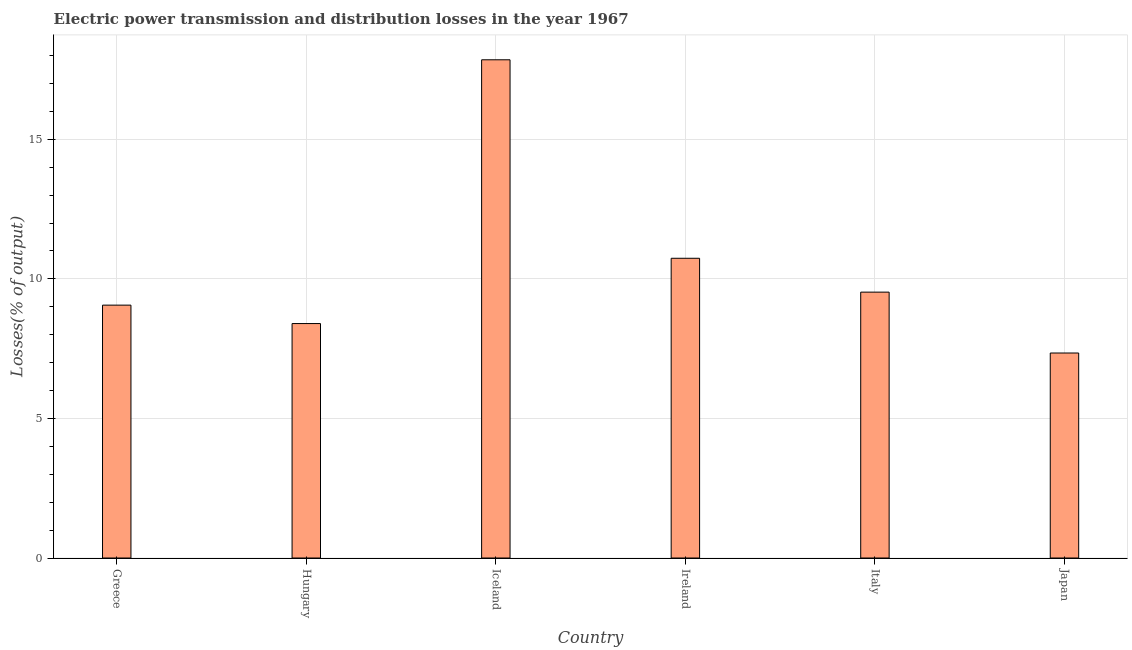Does the graph contain any zero values?
Your answer should be compact. No. What is the title of the graph?
Offer a very short reply. Electric power transmission and distribution losses in the year 1967. What is the label or title of the X-axis?
Your response must be concise. Country. What is the label or title of the Y-axis?
Make the answer very short. Losses(% of output). What is the electric power transmission and distribution losses in Italy?
Your answer should be compact. 9.52. Across all countries, what is the maximum electric power transmission and distribution losses?
Provide a short and direct response. 17.85. Across all countries, what is the minimum electric power transmission and distribution losses?
Keep it short and to the point. 7.34. What is the sum of the electric power transmission and distribution losses?
Offer a very short reply. 62.91. What is the difference between the electric power transmission and distribution losses in Hungary and Japan?
Offer a very short reply. 1.05. What is the average electric power transmission and distribution losses per country?
Your response must be concise. 10.48. What is the median electric power transmission and distribution losses?
Your answer should be very brief. 9.29. In how many countries, is the electric power transmission and distribution losses greater than 14 %?
Offer a terse response. 1. What is the ratio of the electric power transmission and distribution losses in Iceland to that in Italy?
Offer a terse response. 1.87. Is the difference between the electric power transmission and distribution losses in Ireland and Japan greater than the difference between any two countries?
Ensure brevity in your answer.  No. What is the difference between the highest and the second highest electric power transmission and distribution losses?
Ensure brevity in your answer.  7.11. Is the sum of the electric power transmission and distribution losses in Iceland and Ireland greater than the maximum electric power transmission and distribution losses across all countries?
Your answer should be compact. Yes. In how many countries, is the electric power transmission and distribution losses greater than the average electric power transmission and distribution losses taken over all countries?
Offer a very short reply. 2. What is the difference between two consecutive major ticks on the Y-axis?
Your answer should be very brief. 5. Are the values on the major ticks of Y-axis written in scientific E-notation?
Your answer should be compact. No. What is the Losses(% of output) in Greece?
Provide a succinct answer. 9.06. What is the Losses(% of output) in Hungary?
Ensure brevity in your answer.  8.4. What is the Losses(% of output) of Iceland?
Offer a terse response. 17.85. What is the Losses(% of output) in Ireland?
Offer a very short reply. 10.74. What is the Losses(% of output) of Italy?
Your response must be concise. 9.52. What is the Losses(% of output) of Japan?
Offer a very short reply. 7.34. What is the difference between the Losses(% of output) in Greece and Hungary?
Provide a short and direct response. 0.66. What is the difference between the Losses(% of output) in Greece and Iceland?
Keep it short and to the point. -8.79. What is the difference between the Losses(% of output) in Greece and Ireland?
Give a very brief answer. -1.68. What is the difference between the Losses(% of output) in Greece and Italy?
Offer a terse response. -0.47. What is the difference between the Losses(% of output) in Greece and Japan?
Keep it short and to the point. 1.71. What is the difference between the Losses(% of output) in Hungary and Iceland?
Offer a very short reply. -9.45. What is the difference between the Losses(% of output) in Hungary and Ireland?
Make the answer very short. -2.34. What is the difference between the Losses(% of output) in Hungary and Italy?
Offer a very short reply. -1.13. What is the difference between the Losses(% of output) in Hungary and Japan?
Provide a short and direct response. 1.06. What is the difference between the Losses(% of output) in Iceland and Ireland?
Give a very brief answer. 7.11. What is the difference between the Losses(% of output) in Iceland and Italy?
Offer a terse response. 8.32. What is the difference between the Losses(% of output) in Iceland and Japan?
Keep it short and to the point. 10.5. What is the difference between the Losses(% of output) in Ireland and Italy?
Provide a succinct answer. 1.21. What is the difference between the Losses(% of output) in Ireland and Japan?
Your response must be concise. 3.39. What is the difference between the Losses(% of output) in Italy and Japan?
Make the answer very short. 2.18. What is the ratio of the Losses(% of output) in Greece to that in Hungary?
Your answer should be compact. 1.08. What is the ratio of the Losses(% of output) in Greece to that in Iceland?
Your answer should be compact. 0.51. What is the ratio of the Losses(% of output) in Greece to that in Ireland?
Make the answer very short. 0.84. What is the ratio of the Losses(% of output) in Greece to that in Italy?
Offer a terse response. 0.95. What is the ratio of the Losses(% of output) in Greece to that in Japan?
Your response must be concise. 1.23. What is the ratio of the Losses(% of output) in Hungary to that in Iceland?
Provide a short and direct response. 0.47. What is the ratio of the Losses(% of output) in Hungary to that in Ireland?
Provide a succinct answer. 0.78. What is the ratio of the Losses(% of output) in Hungary to that in Italy?
Give a very brief answer. 0.88. What is the ratio of the Losses(% of output) in Hungary to that in Japan?
Keep it short and to the point. 1.14. What is the ratio of the Losses(% of output) in Iceland to that in Ireland?
Your response must be concise. 1.66. What is the ratio of the Losses(% of output) in Iceland to that in Italy?
Ensure brevity in your answer.  1.87. What is the ratio of the Losses(% of output) in Iceland to that in Japan?
Keep it short and to the point. 2.43. What is the ratio of the Losses(% of output) in Ireland to that in Italy?
Your answer should be very brief. 1.13. What is the ratio of the Losses(% of output) in Ireland to that in Japan?
Make the answer very short. 1.46. What is the ratio of the Losses(% of output) in Italy to that in Japan?
Ensure brevity in your answer.  1.3. 